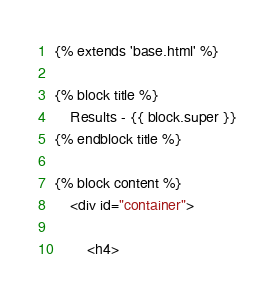<code> <loc_0><loc_0><loc_500><loc_500><_HTML_>{% extends 'base.html' %}

{% block title %}
	Results - {{ block.super }}
{% endblock title %}

{% block content %}
	<div id="container">

		<h4></code> 